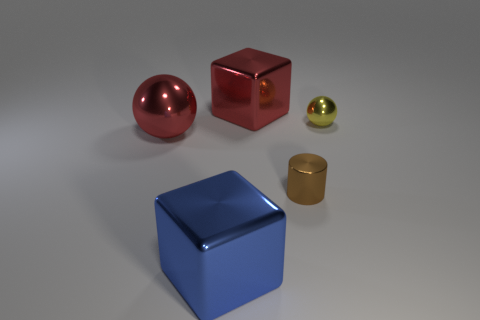How many yellow things are shiny cylinders or tiny spheres?
Provide a short and direct response. 1. What number of big shiny things have the same color as the small shiny cylinder?
Your response must be concise. 0. Is the material of the blue cube the same as the yellow ball?
Keep it short and to the point. Yes. How many blocks are behind the sphere that is to the left of the tiny brown thing?
Make the answer very short. 1. Is the red sphere the same size as the brown metal cylinder?
Provide a succinct answer. No. What number of tiny things have the same material as the brown cylinder?
Keep it short and to the point. 1. There is another metal object that is the same shape as the blue thing; what is its size?
Give a very brief answer. Large. Do the shiny thing on the left side of the blue thing and the yellow metallic object have the same shape?
Give a very brief answer. Yes. What shape is the red object behind the metallic thing on the right side of the small brown metal cylinder?
Offer a very short reply. Cube. Is there any other thing that is the same shape as the small yellow shiny object?
Give a very brief answer. Yes. 